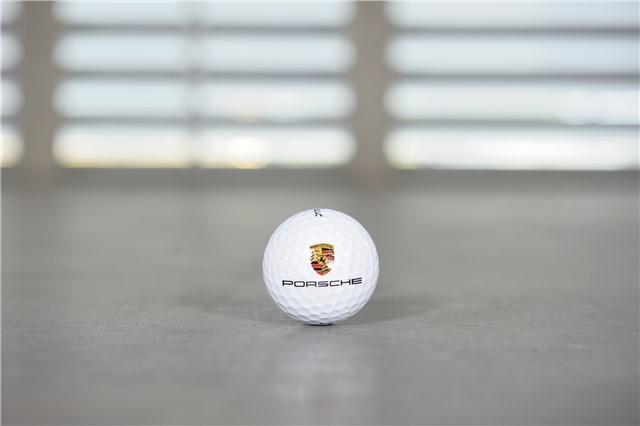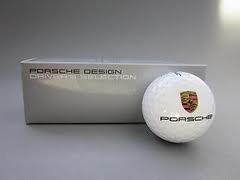The first image is the image on the left, the second image is the image on the right. Examine the images to the left and right. Is the description "An image shows a group of exactly three white golf balls with the same logos printed on them." accurate? Answer yes or no. No. The first image is the image on the left, the second image is the image on the right. Evaluate the accuracy of this statement regarding the images: "The right image contains at least three golf balls.". Is it true? Answer yes or no. No. 